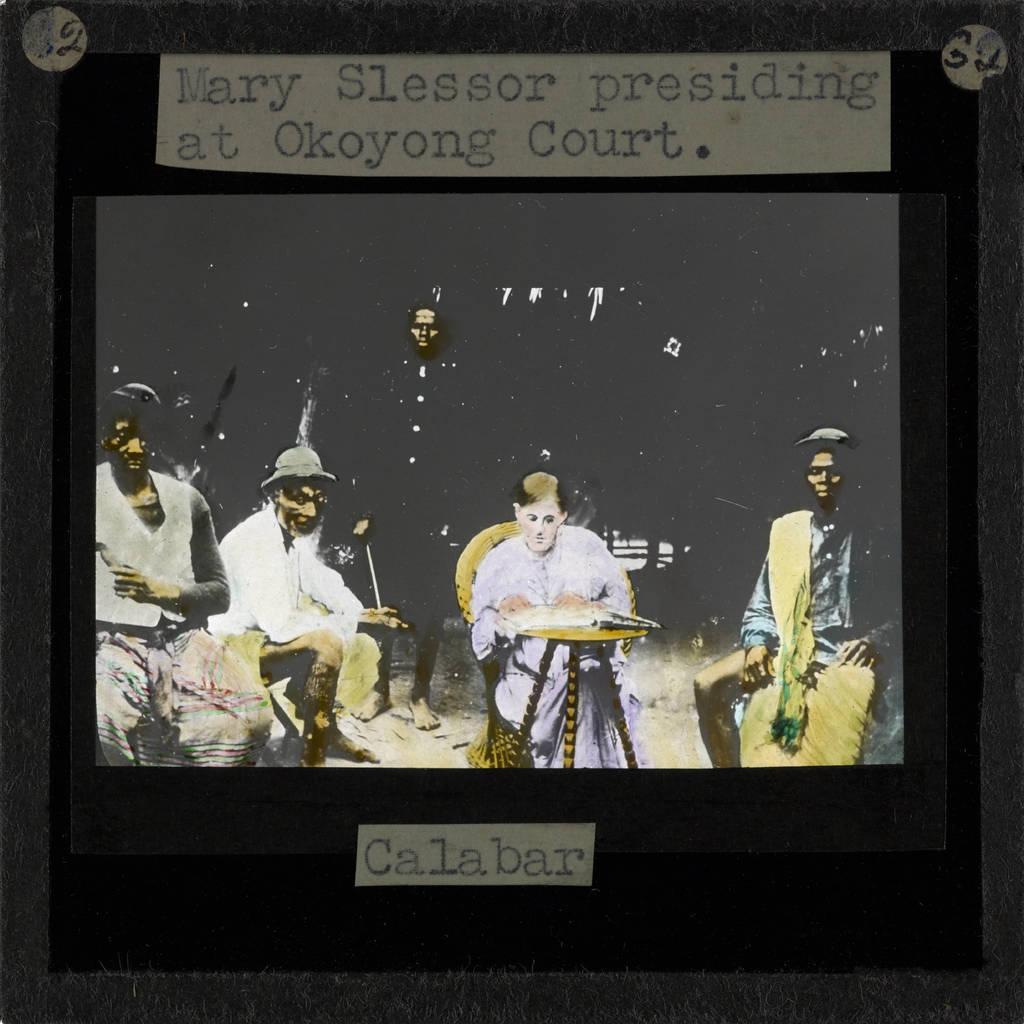How would you summarize this image in a sentence or two? In the picture I can see depiction of people. I can also see something written on objects. 